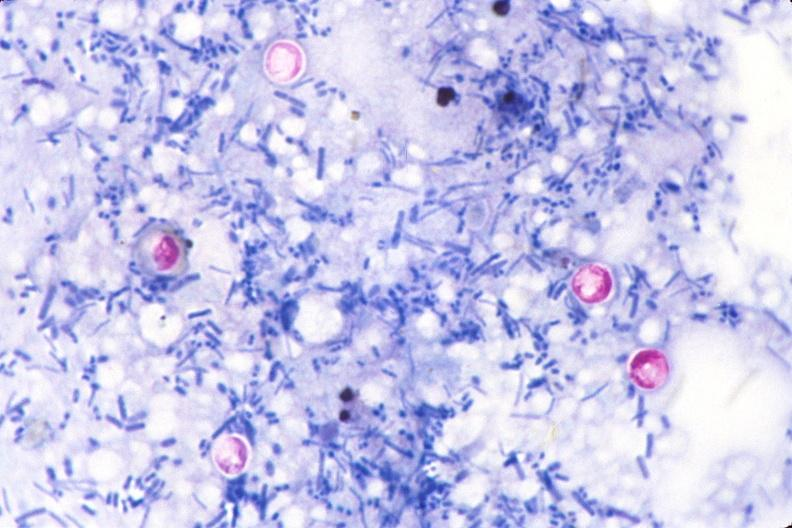what stain of feces?
Answer the question using a single word or phrase. Acid 